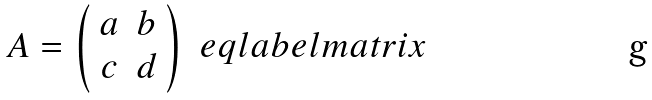Convert formula to latex. <formula><loc_0><loc_0><loc_500><loc_500>A = \left ( \begin{array} { c c } a & b \\ c & d \\ \end{array} \right ) \ e q l a b e l { m a t r i x }</formula> 